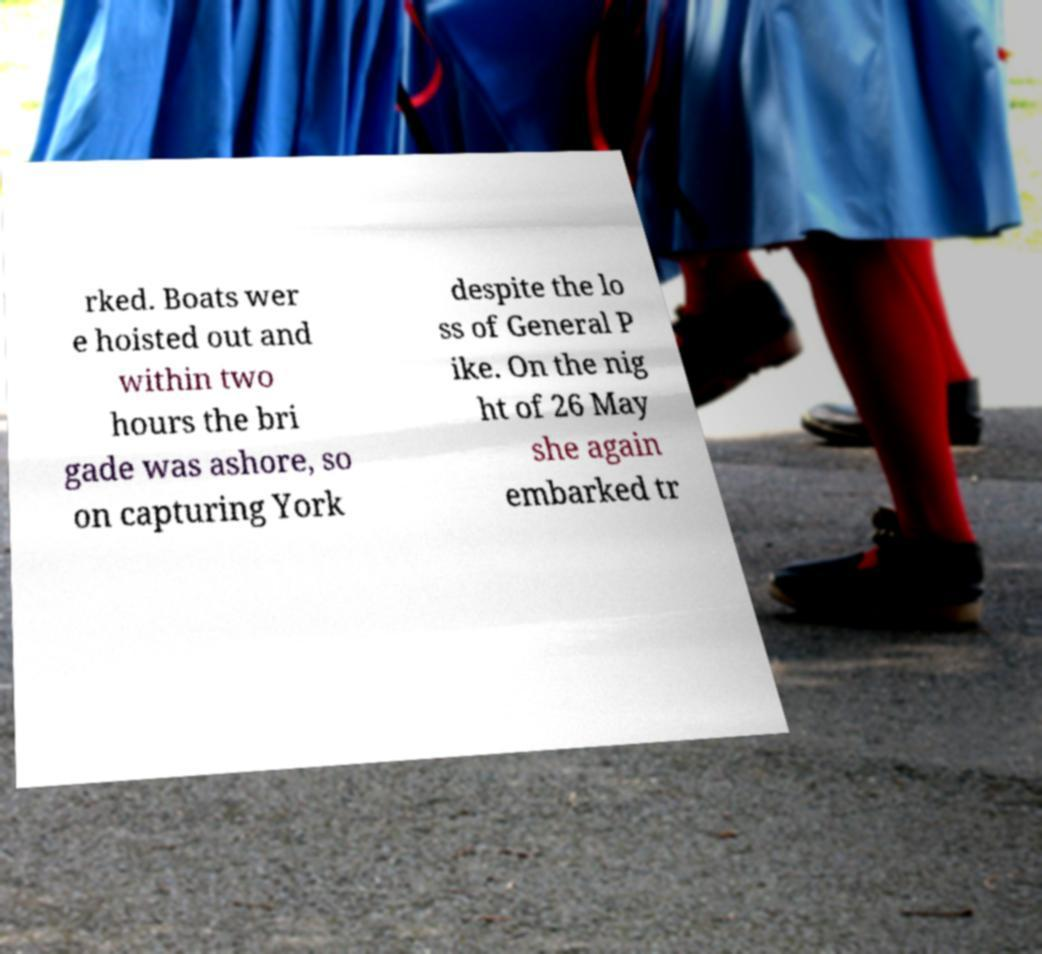Could you extract and type out the text from this image? rked. Boats wer e hoisted out and within two hours the bri gade was ashore, so on capturing York despite the lo ss of General P ike. On the nig ht of 26 May she again embarked tr 